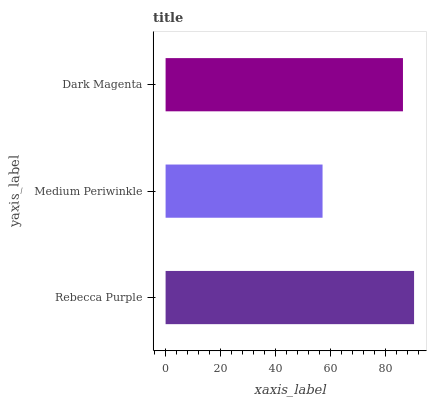Is Medium Periwinkle the minimum?
Answer yes or no. Yes. Is Rebecca Purple the maximum?
Answer yes or no. Yes. Is Dark Magenta the minimum?
Answer yes or no. No. Is Dark Magenta the maximum?
Answer yes or no. No. Is Dark Magenta greater than Medium Periwinkle?
Answer yes or no. Yes. Is Medium Periwinkle less than Dark Magenta?
Answer yes or no. Yes. Is Medium Periwinkle greater than Dark Magenta?
Answer yes or no. No. Is Dark Magenta less than Medium Periwinkle?
Answer yes or no. No. Is Dark Magenta the high median?
Answer yes or no. Yes. Is Dark Magenta the low median?
Answer yes or no. Yes. Is Rebecca Purple the high median?
Answer yes or no. No. Is Rebecca Purple the low median?
Answer yes or no. No. 